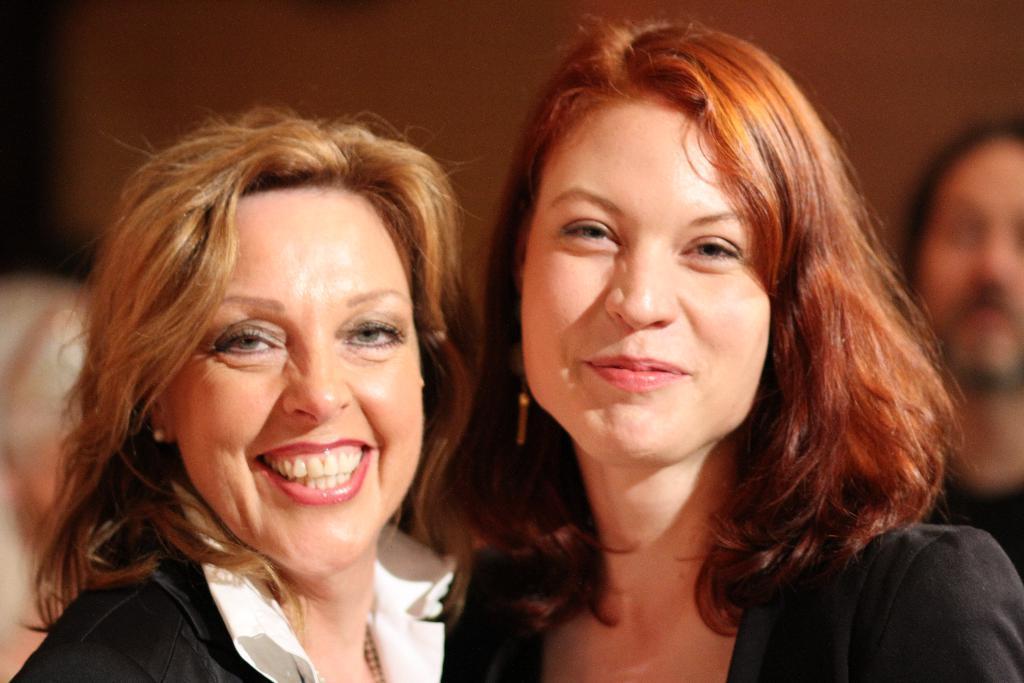In one or two sentences, can you explain what this image depicts? In this image, in the middle, we can see two women who are wearing black color jacket. In the background, we can also see a group of people and black color wall. 